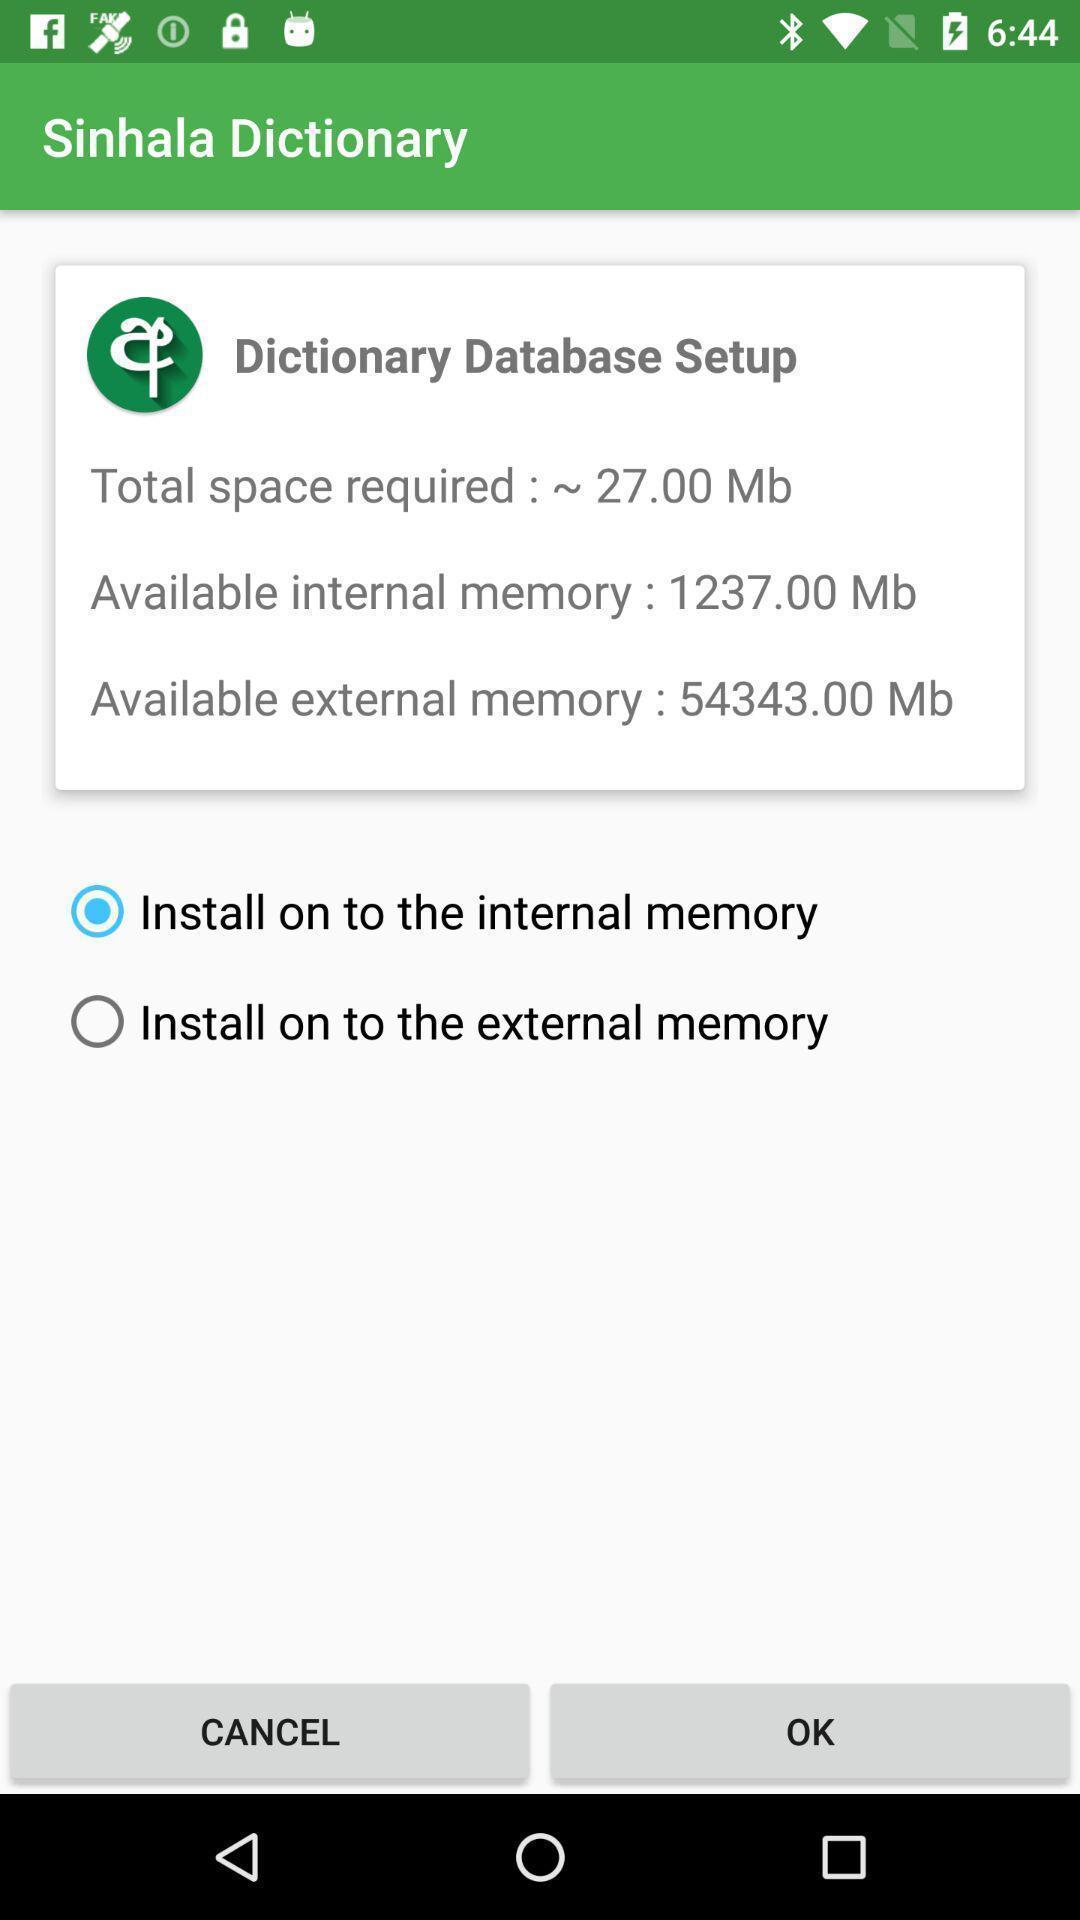Explain the elements present in this screenshot. Window displaying an offline dictionary. 